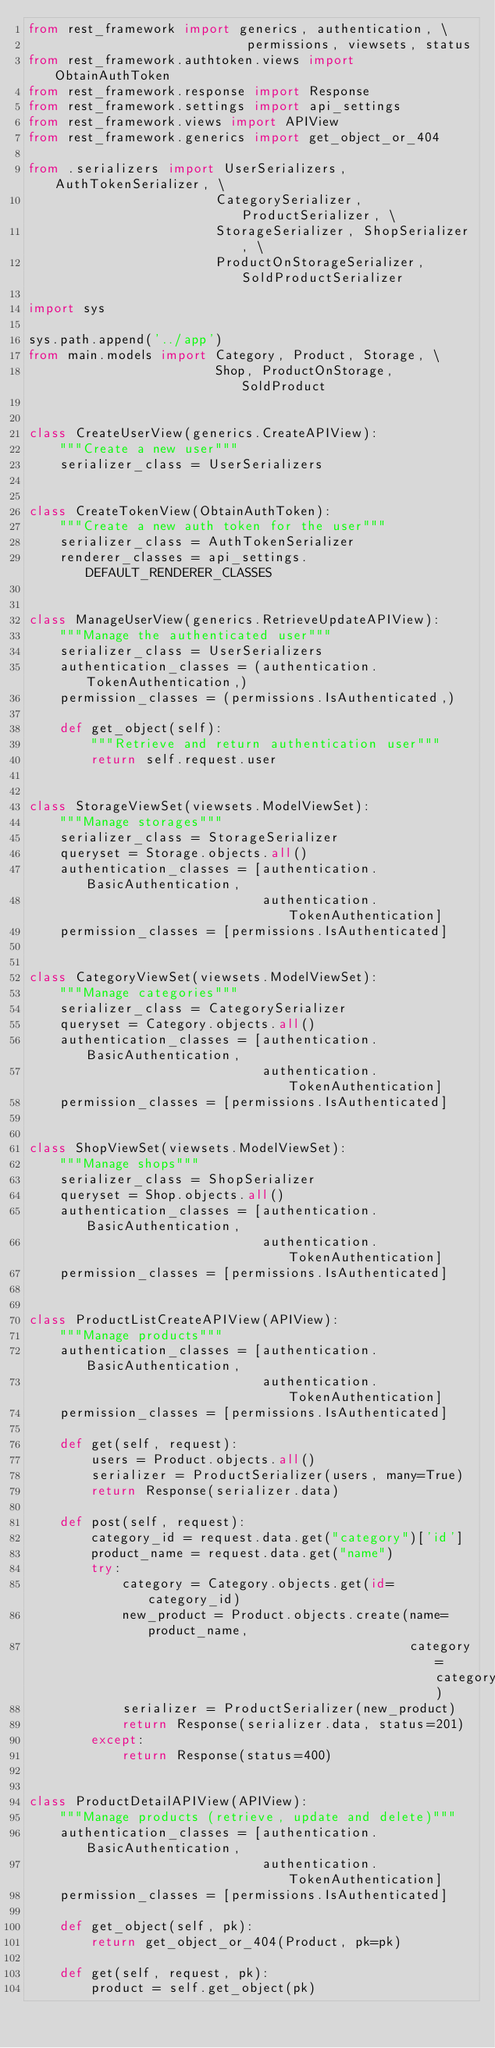<code> <loc_0><loc_0><loc_500><loc_500><_Python_>from rest_framework import generics, authentication, \
                            permissions, viewsets, status
from rest_framework.authtoken.views import ObtainAuthToken
from rest_framework.response import Response
from rest_framework.settings import api_settings
from rest_framework.views import APIView
from rest_framework.generics import get_object_or_404

from .serializers import UserSerializers, AuthTokenSerializer, \
                        CategorySerializer, ProductSerializer, \
                        StorageSerializer, ShopSerializer, \
                        ProductOnStorageSerializer, SoldProductSerializer

import sys

sys.path.append('../app')
from main.models import Category, Product, Storage, \
                        Shop, ProductOnStorage, SoldProduct


class CreateUserView(generics.CreateAPIView):
    """Create a new user"""
    serializer_class = UserSerializers


class CreateTokenView(ObtainAuthToken):
    """Create a new auth token for the user"""
    serializer_class = AuthTokenSerializer
    renderer_classes = api_settings.DEFAULT_RENDERER_CLASSES


class ManageUserView(generics.RetrieveUpdateAPIView):
    """Manage the authenticated user"""
    serializer_class = UserSerializers
    authentication_classes = (authentication.TokenAuthentication,)
    permission_classes = (permissions.IsAuthenticated,)

    def get_object(self):
        """Retrieve and return authentication user"""
        return self.request.user


class StorageViewSet(viewsets.ModelViewSet):
    """Manage storages"""
    serializer_class = StorageSerializer
    queryset = Storage.objects.all()
    authentication_classes = [authentication.BasicAuthentication,
                              authentication.TokenAuthentication]
    permission_classes = [permissions.IsAuthenticated]


class CategoryViewSet(viewsets.ModelViewSet):
    """Manage categories"""
    serializer_class = CategorySerializer
    queryset = Category.objects.all()
    authentication_classes = [authentication.BasicAuthentication,
                              authentication.TokenAuthentication]
    permission_classes = [permissions.IsAuthenticated]


class ShopViewSet(viewsets.ModelViewSet):
    """Manage shops"""
    serializer_class = ShopSerializer
    queryset = Shop.objects.all()
    authentication_classes = [authentication.BasicAuthentication,
                              authentication.TokenAuthentication]
    permission_classes = [permissions.IsAuthenticated]


class ProductListCreateAPIView(APIView):
    """Manage products"""
    authentication_classes = [authentication.BasicAuthentication,
                              authentication.TokenAuthentication]
    permission_classes = [permissions.IsAuthenticated]

    def get(self, request):
        users = Product.objects.all()
        serializer = ProductSerializer(users, many=True)
        return Response(serializer.data)

    def post(self, request):
        category_id = request.data.get("category")['id']
        product_name = request.data.get("name")
        try:
            category = Category.objects.get(id=category_id)
            new_product = Product.objects.create(name=product_name,
                                                 category=category)
            serializer = ProductSerializer(new_product)
            return Response(serializer.data, status=201)
        except:
            return Response(status=400)


class ProductDetailAPIView(APIView):
    """Manage products (retrieve, update and delete)"""
    authentication_classes = [authentication.BasicAuthentication,
                              authentication.TokenAuthentication]
    permission_classes = [permissions.IsAuthenticated]

    def get_object(self, pk):
        return get_object_or_404(Product, pk=pk)

    def get(self, request, pk):
        product = self.get_object(pk)</code> 